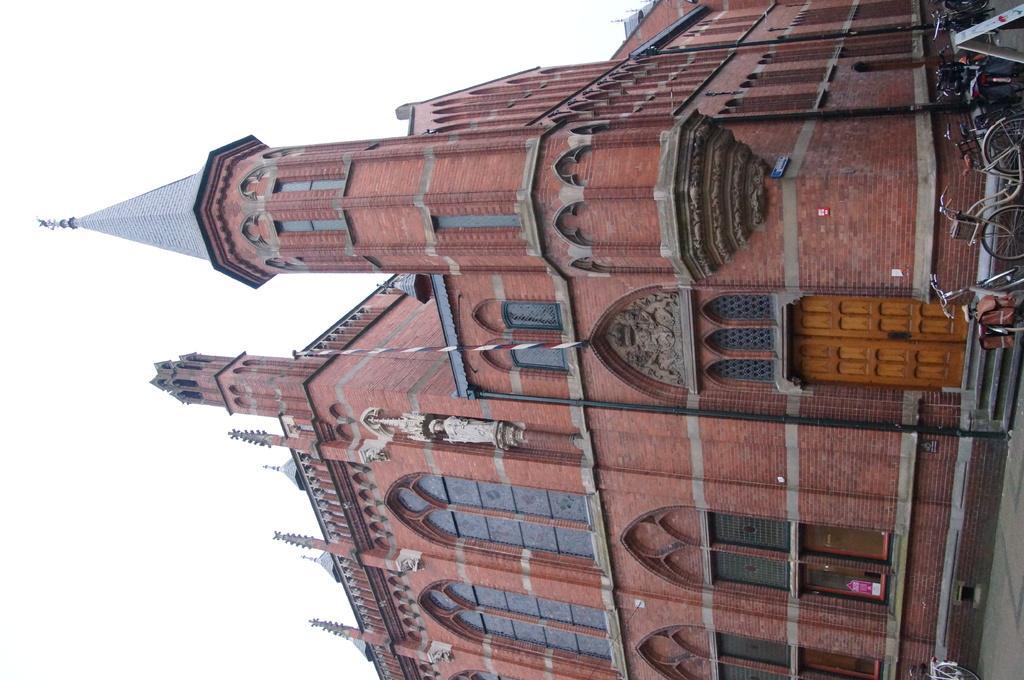Could you give a brief overview of what you see in this image? This picture is clicked outside the city. In this picture, we see a building in red color. We even see doors and windows of that building. On the right corner of the picture, we see bicycles parked on the road. Beside that, we see a staircase. On the left side of the picture, we see the sky. 